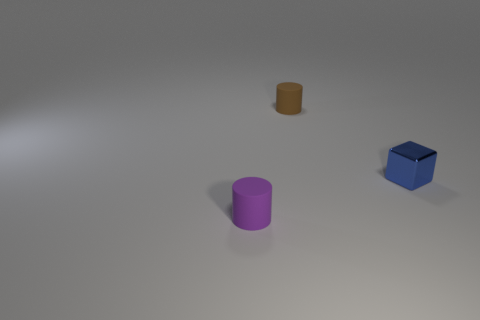Subtract 0 green cylinders. How many objects are left? 3 Subtract all cylinders. How many objects are left? 1 Subtract 1 cubes. How many cubes are left? 0 Subtract all purple cylinders. Subtract all brown balls. How many cylinders are left? 1 Subtract all blue spheres. How many green cubes are left? 0 Subtract all brown things. Subtract all matte objects. How many objects are left? 0 Add 1 blue metal things. How many blue metal things are left? 2 Add 2 tiny cylinders. How many tiny cylinders exist? 4 Add 1 big blue metallic blocks. How many objects exist? 4 Subtract all brown cylinders. How many cylinders are left? 1 